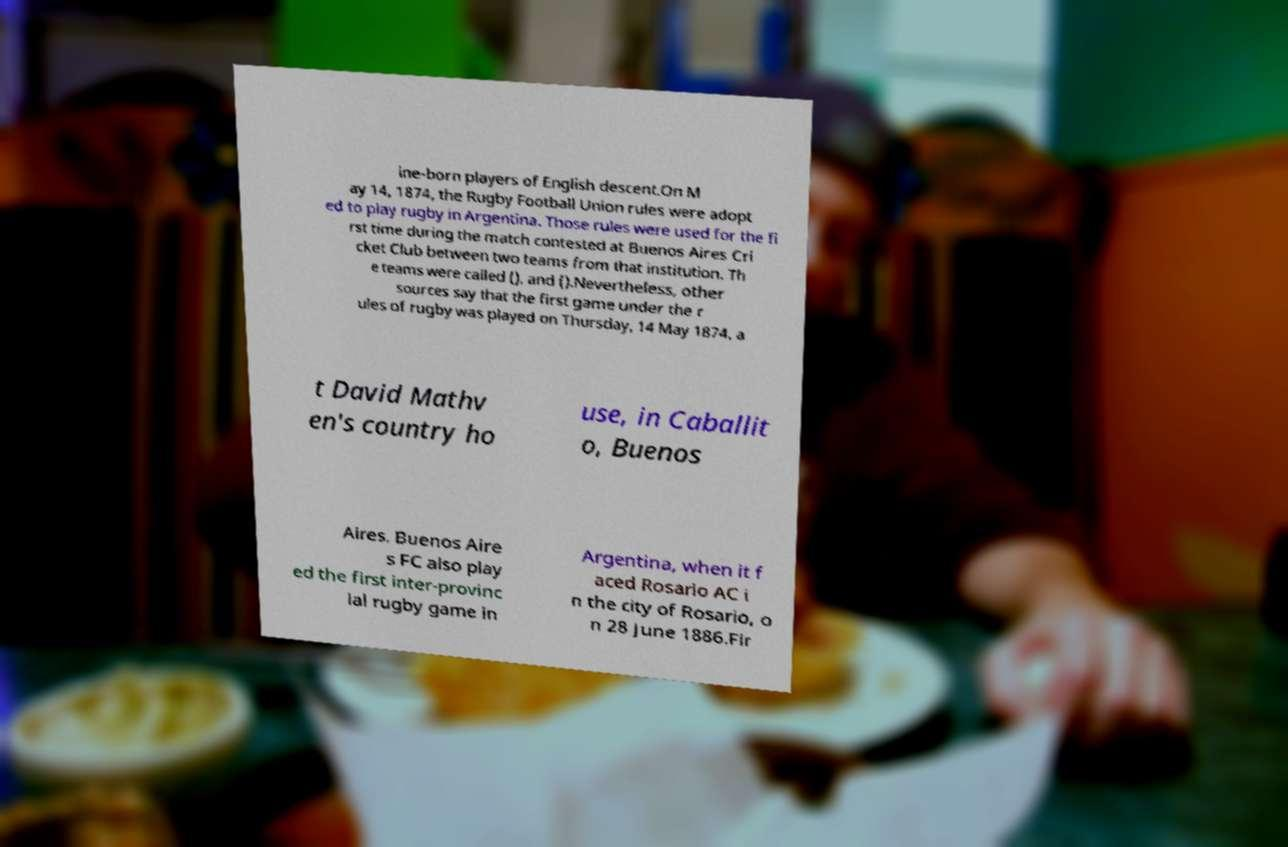I need the written content from this picture converted into text. Can you do that? ine-born players of English descent.On M ay 14, 1874, the Rugby Football Union rules were adopt ed to play rugby in Argentina. Those rules were used for the fi rst time during the match contested at Buenos Aires Cri cket Club between two teams from that institution. Th e teams were called (), and ().Nevertheless, other sources say that the first game under the r ules of rugby was played on Thursday, 14 May 1874, a t David Mathv en's country ho use, in Caballit o, Buenos Aires. Buenos Aire s FC also play ed the first inter-provinc ial rugby game in Argentina, when it f aced Rosario AC i n the city of Rosario, o n 28 June 1886.Fir 